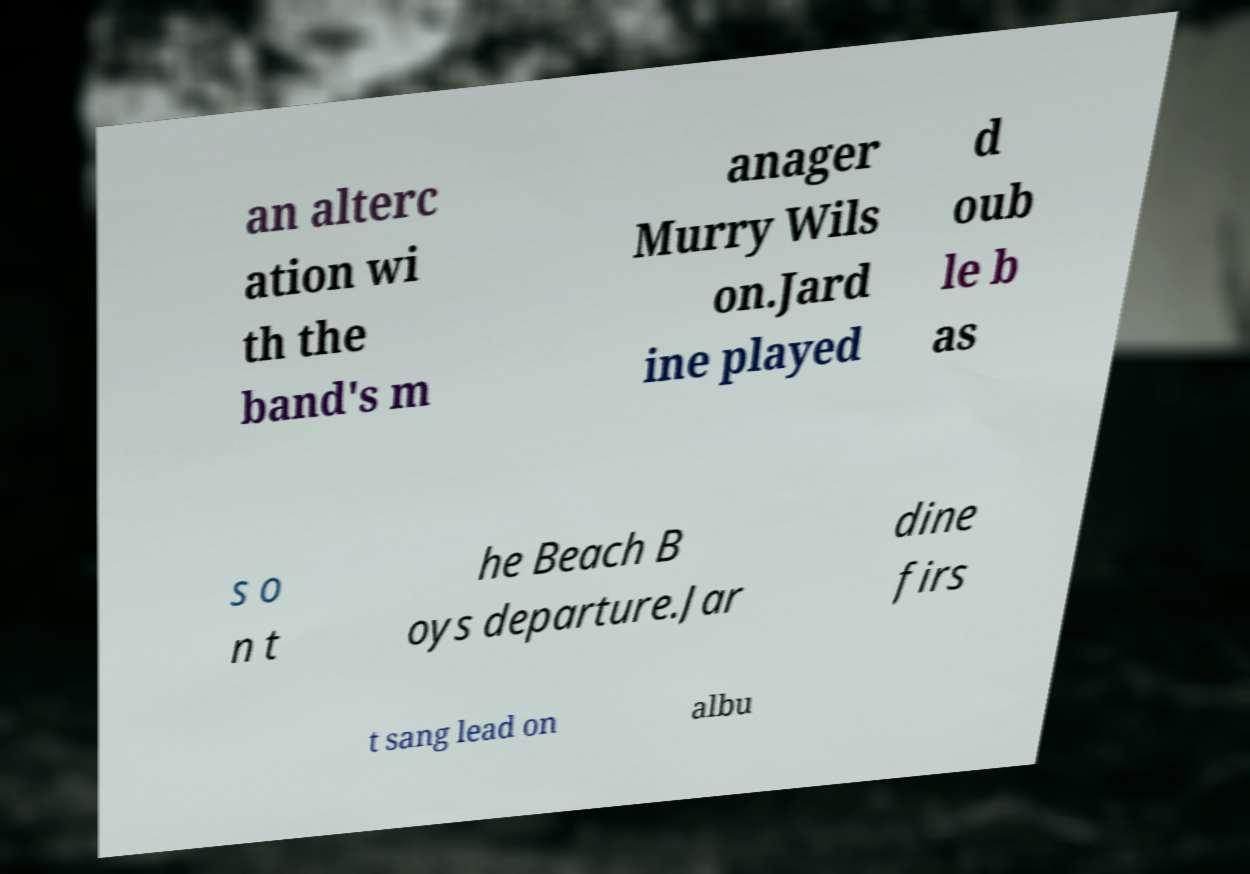What messages or text are displayed in this image? I need them in a readable, typed format. an alterc ation wi th the band's m anager Murry Wils on.Jard ine played d oub le b as s o n t he Beach B oys departure.Jar dine firs t sang lead on albu 